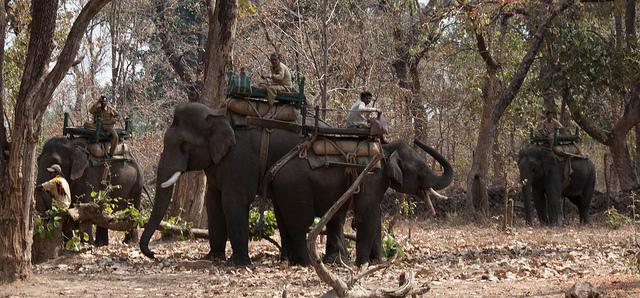Are these animals very tall?
Be succinct. Yes. Was the photo taken in a forest or on a city street?
Give a very brief answer. Forest. What animal is in the picture?
Answer briefly. Elephant. How many elephants can you see?
Answer briefly. 4. Are there people riding the elephant?
Keep it brief. Yes. Hazy or sunny?
Concise answer only. Sunny. Is the man feeding an elephant?
Concise answer only. No. What is between the man and the elephant?
Quick response, please. Seat. What kind of animals are gathered in this scene?
Answer briefly. Elephants. What type of animals are these?
Write a very short answer. Elephants. Would you find this animal at a petting zoo?
Be succinct. No. What color is the elephant?
Short answer required. Black. What are these people riding?
Concise answer only. Elephants. Are the animals looking for food?
Quick response, please. No. What are surrounding the elephant?
Short answer required. Trees. What are the people riding in?
Be succinct. Elephant. What kind of sleeves does the man's shirt have?
Quick response, please. Long. What are the people riding on?
Keep it brief. Elephant. What are the animals in the picture?
Be succinct. Elephants. 